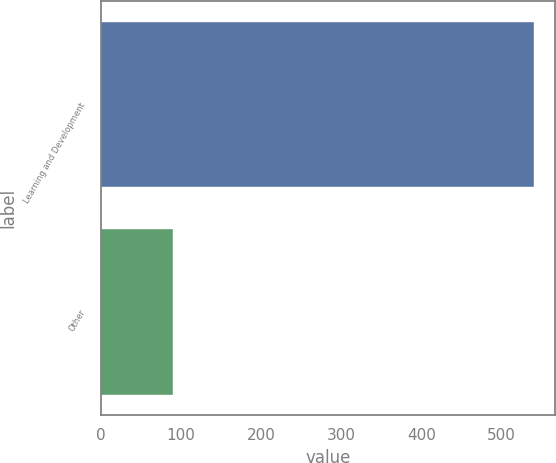Convert chart. <chart><loc_0><loc_0><loc_500><loc_500><bar_chart><fcel>Learning and Development<fcel>Other<nl><fcel>540.4<fcel>89.5<nl></chart> 